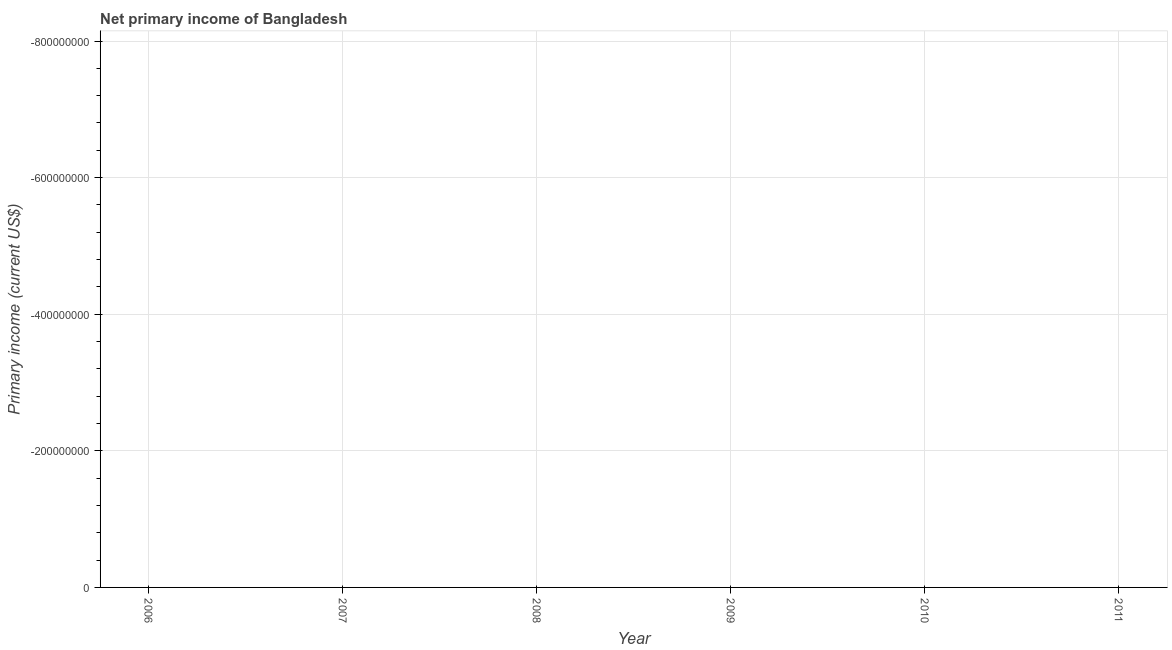What is the amount of primary income in 2011?
Your response must be concise. 0. In how many years, is the amount of primary income greater than -320000000 US$?
Offer a terse response. 0. Does the amount of primary income monotonically increase over the years?
Provide a short and direct response. No. Are the values on the major ticks of Y-axis written in scientific E-notation?
Ensure brevity in your answer.  No. Does the graph contain any zero values?
Offer a terse response. Yes. Does the graph contain grids?
Your answer should be compact. Yes. What is the title of the graph?
Your response must be concise. Net primary income of Bangladesh. What is the label or title of the X-axis?
Offer a terse response. Year. What is the label or title of the Y-axis?
Give a very brief answer. Primary income (current US$). 